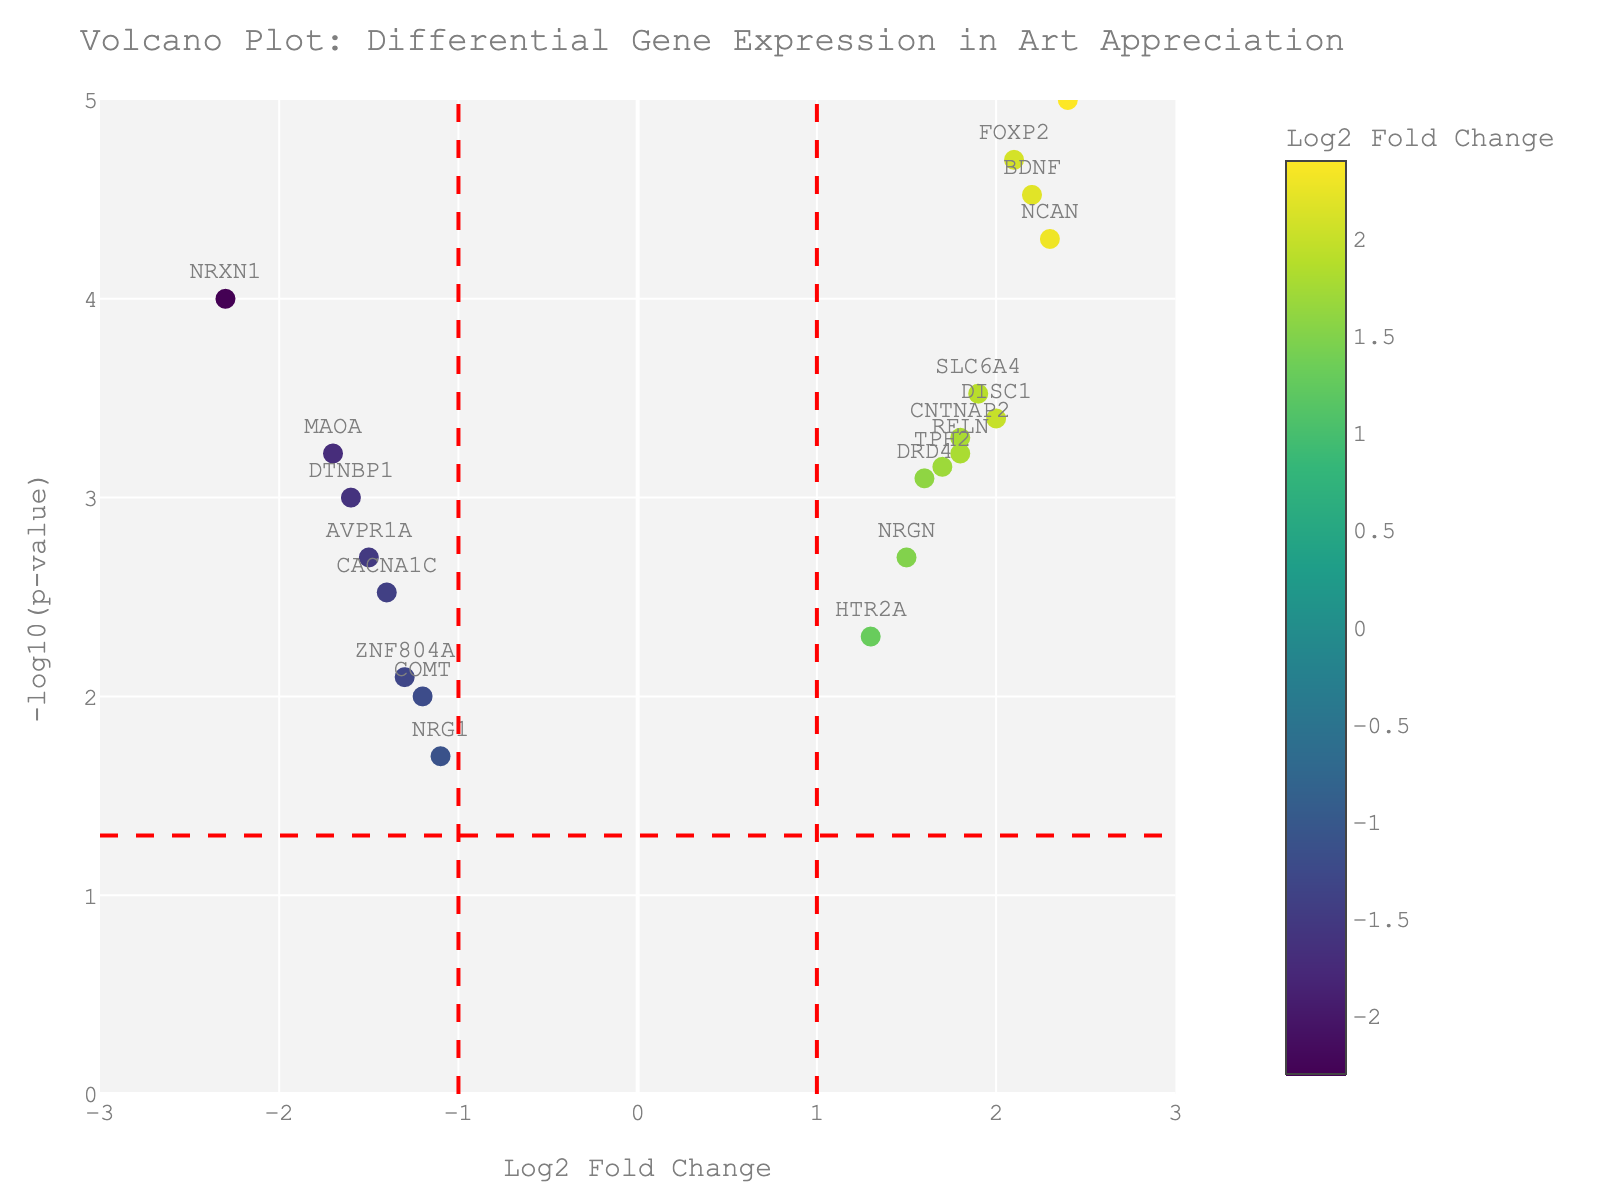What is the title of the plot? The title of the plot is located at the top and is meant to convey the main purpose or subject being displayed in the figure. Look at the center top of the plot to read the title.
Answer: Volcano Plot: Differential Gene Expression in Art Appreciation How many genes have a Log2 Fold Change greater than 2? To determine this, identify the data points on the x-axis which have a Log2 Fold Change value greater than 2. There are four such genes displayed on the right side of the plot showing values greater than 2.
Answer: 4 Which gene demonstrates the highest -log10(p-value)? To find this, look at the y-axis which represents the -log10(p-value) and identify the data point that reaches the highest vertical position. The gene labeled "OXTR" reaches the highest point.
Answer: OXTR Are there more upregulated or downregulated genes with significant p-values? Upregulated genes have positive Log2 Fold Change values, while downregulated genes have negative Log2 Fold Change values. Look at the number of significant genes (p-value < 0.05) on both the left (negative values) and right (positive values) sides. Upregulated genes with significant p-values outnumber downregulated in the plot.
Answer: More upregulated Which gene has the most extreme negative Log2 Fold Change? This can be found by identifying the leftmost data point on the x-axis which represents the gene with the lowest (most negative) Log2 Fold Change value. "NRXN1" is the leftmost point with a Log2 Fold Change of -2.3.
Answer: NRXN1 How many genes have a p-value less than 0.0001? -log10(p-value) = 4 corresponds to p-value of 0.0001, so find all points positioned above y=4. There are three such points on the plot.
Answer: 3 What color represents the lowest Log2 Fold Change values? The color scale (Viridis) on the plot bar indicates that lower values are represented by purple shades and higher values transition to yellow.
Answer: Purple How does the gene "BDNF" compare to "COMT" in terms of Log2 Fold Change? Locate both genes on the plot and compare their positions along the x-axis. "BDNF" has a Log2 Fold Change of 2.2, while "COMT" has a value of -1.2. "BDNF" is therefore more upregulated compared to "COMT".
Answer: BDNF is more upregulated What are the axes titles of the plot? The x-axis title is 'Log2 Fold Change' and the y-axis title is '-log10(p-value)'. These labels help to understand what each axis represents in the data.
Answer: Log2 Fold Change (x-axis), -log10(p-value) (y-axis) After how many units does a vertical dashed red line appear on the x-axis? Vertical dashed red lines typically signify thresholds and they are positioned at x = -1 and x = 1. Measure the distance between these lines to find that they are 2 units apart.
Answer: 2 units 